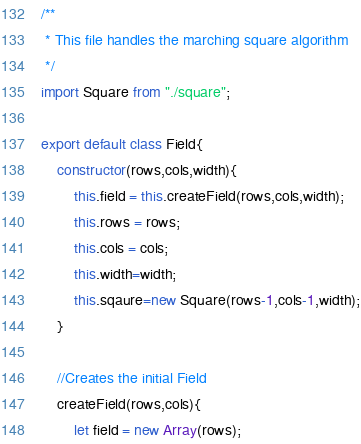<code> <loc_0><loc_0><loc_500><loc_500><_JavaScript_>/**
 * This file handles the marching square algorithm
 */
import Square from "./square";

export default class Field{
    constructor(rows,cols,width){
        this.field = this.createField(rows,cols,width);
        this.rows = rows;
        this.cols = cols;
        this.width=width;
        this.sqaure=new Square(rows-1,cols-1,width);
    }

    //Creates the initial Field
    createField(rows,cols){
        let field = new Array(rows);</code> 